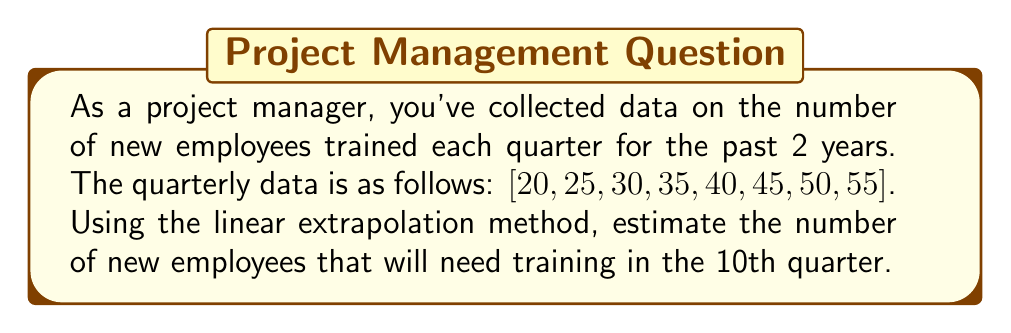Provide a solution to this math problem. To solve this problem using linear extrapolation, we'll follow these steps:

1. Identify the data points:
   We have 8 data points representing 8 quarters.

2. Calculate the average rate of change:
   $$ \text{Rate of change} = \frac{\text{Last value} - \text{First value}}{\text{Number of intervals}} $$
   $$ = \frac{55 - 20}{7} = 5 \text{ employees/quarter} $$

3. Use the linear extrapolation formula:
   $$ y = y_n + m(x - x_n) $$
   Where:
   $y$ is the extrapolated value
   $y_n$ is the last known value (55)
   $m$ is the rate of change (5)
   $x$ is the quarter we're predicting (10)
   $x_n$ is the last known quarter (8)

4. Plug in the values:
   $$ y = 55 + 5(10 - 8) $$
   $$ y = 55 + 5(2) $$
   $$ y = 55 + 10 $$
   $$ y = 65 $$

Therefore, based on linear extrapolation, we estimate that 65 new employees will need training in the 10th quarter.
Answer: 65 employees 